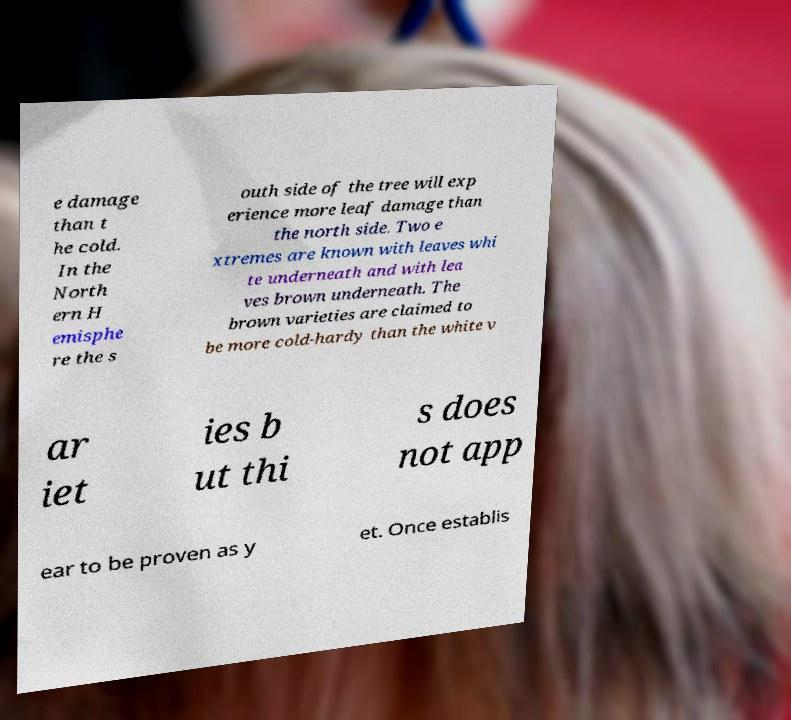What messages or text are displayed in this image? I need them in a readable, typed format. e damage than t he cold. In the North ern H emisphe re the s outh side of the tree will exp erience more leaf damage than the north side. Two e xtremes are known with leaves whi te underneath and with lea ves brown underneath. The brown varieties are claimed to be more cold-hardy than the white v ar iet ies b ut thi s does not app ear to be proven as y et. Once establis 